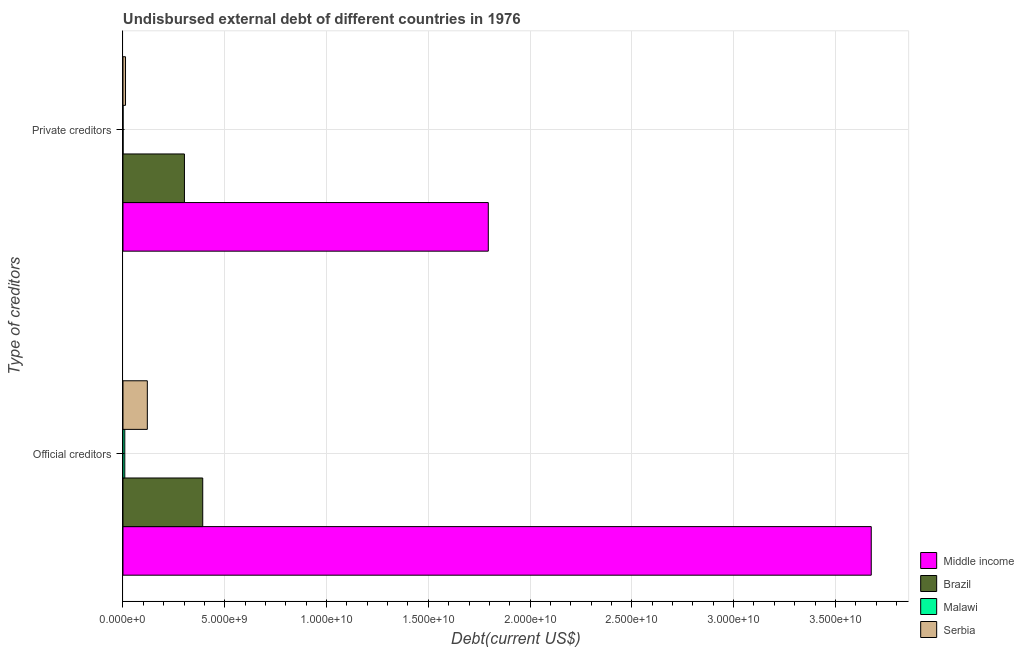How many different coloured bars are there?
Provide a short and direct response. 4. How many groups of bars are there?
Give a very brief answer. 2. Are the number of bars per tick equal to the number of legend labels?
Offer a very short reply. Yes. Are the number of bars on each tick of the Y-axis equal?
Your answer should be very brief. Yes. How many bars are there on the 2nd tick from the top?
Give a very brief answer. 4. What is the label of the 1st group of bars from the top?
Your answer should be very brief. Private creditors. What is the undisbursed external debt of private creditors in Malawi?
Your answer should be compact. 3.15e+06. Across all countries, what is the maximum undisbursed external debt of private creditors?
Offer a very short reply. 1.79e+1. Across all countries, what is the minimum undisbursed external debt of official creditors?
Make the answer very short. 8.95e+07. In which country was the undisbursed external debt of official creditors maximum?
Your answer should be very brief. Middle income. In which country was the undisbursed external debt of official creditors minimum?
Offer a terse response. Malawi. What is the total undisbursed external debt of private creditors in the graph?
Give a very brief answer. 2.11e+1. What is the difference between the undisbursed external debt of private creditors in Serbia and that in Brazil?
Offer a terse response. -2.89e+09. What is the difference between the undisbursed external debt of official creditors in Serbia and the undisbursed external debt of private creditors in Malawi?
Your answer should be very brief. 1.19e+09. What is the average undisbursed external debt of private creditors per country?
Provide a short and direct response. 5.27e+09. What is the difference between the undisbursed external debt of private creditors and undisbursed external debt of official creditors in Malawi?
Provide a succinct answer. -8.64e+07. In how many countries, is the undisbursed external debt of private creditors greater than 8000000000 US$?
Offer a very short reply. 1. What is the ratio of the undisbursed external debt of private creditors in Brazil to that in Malawi?
Provide a succinct answer. 958.53. In how many countries, is the undisbursed external debt of official creditors greater than the average undisbursed external debt of official creditors taken over all countries?
Offer a terse response. 1. What does the 3rd bar from the top in Private creditors represents?
Your answer should be compact. Brazil. How many countries are there in the graph?
Your answer should be very brief. 4. Are the values on the major ticks of X-axis written in scientific E-notation?
Provide a succinct answer. Yes. Does the graph contain any zero values?
Your answer should be very brief. No. Does the graph contain grids?
Give a very brief answer. Yes. How many legend labels are there?
Your answer should be very brief. 4. How are the legend labels stacked?
Keep it short and to the point. Vertical. What is the title of the graph?
Keep it short and to the point. Undisbursed external debt of different countries in 1976. What is the label or title of the X-axis?
Provide a succinct answer. Debt(current US$). What is the label or title of the Y-axis?
Your response must be concise. Type of creditors. What is the Debt(current US$) in Middle income in Official creditors?
Offer a very short reply. 3.68e+1. What is the Debt(current US$) of Brazil in Official creditors?
Keep it short and to the point. 3.92e+09. What is the Debt(current US$) of Malawi in Official creditors?
Offer a terse response. 8.95e+07. What is the Debt(current US$) in Serbia in Official creditors?
Your answer should be compact. 1.20e+09. What is the Debt(current US$) in Middle income in Private creditors?
Offer a very short reply. 1.79e+1. What is the Debt(current US$) of Brazil in Private creditors?
Offer a terse response. 3.02e+09. What is the Debt(current US$) in Malawi in Private creditors?
Your answer should be compact. 3.15e+06. What is the Debt(current US$) in Serbia in Private creditors?
Offer a very short reply. 1.24e+08. Across all Type of creditors, what is the maximum Debt(current US$) in Middle income?
Offer a very short reply. 3.68e+1. Across all Type of creditors, what is the maximum Debt(current US$) in Brazil?
Your answer should be compact. 3.92e+09. Across all Type of creditors, what is the maximum Debt(current US$) of Malawi?
Give a very brief answer. 8.95e+07. Across all Type of creditors, what is the maximum Debt(current US$) in Serbia?
Provide a short and direct response. 1.20e+09. Across all Type of creditors, what is the minimum Debt(current US$) of Middle income?
Your answer should be very brief. 1.79e+1. Across all Type of creditors, what is the minimum Debt(current US$) in Brazil?
Your response must be concise. 3.02e+09. Across all Type of creditors, what is the minimum Debt(current US$) of Malawi?
Provide a short and direct response. 3.15e+06. Across all Type of creditors, what is the minimum Debt(current US$) in Serbia?
Provide a succinct answer. 1.24e+08. What is the total Debt(current US$) of Middle income in the graph?
Ensure brevity in your answer.  5.47e+1. What is the total Debt(current US$) of Brazil in the graph?
Your answer should be compact. 6.94e+09. What is the total Debt(current US$) in Malawi in the graph?
Provide a short and direct response. 9.27e+07. What is the total Debt(current US$) of Serbia in the graph?
Your answer should be very brief. 1.32e+09. What is the difference between the Debt(current US$) in Middle income in Official creditors and that in Private creditors?
Your answer should be compact. 1.88e+1. What is the difference between the Debt(current US$) in Brazil in Official creditors and that in Private creditors?
Give a very brief answer. 8.99e+08. What is the difference between the Debt(current US$) of Malawi in Official creditors and that in Private creditors?
Your answer should be very brief. 8.64e+07. What is the difference between the Debt(current US$) of Serbia in Official creditors and that in Private creditors?
Keep it short and to the point. 1.07e+09. What is the difference between the Debt(current US$) of Middle income in Official creditors and the Debt(current US$) of Brazil in Private creditors?
Ensure brevity in your answer.  3.37e+1. What is the difference between the Debt(current US$) in Middle income in Official creditors and the Debt(current US$) in Malawi in Private creditors?
Your response must be concise. 3.68e+1. What is the difference between the Debt(current US$) of Middle income in Official creditors and the Debt(current US$) of Serbia in Private creditors?
Provide a short and direct response. 3.66e+1. What is the difference between the Debt(current US$) in Brazil in Official creditors and the Debt(current US$) in Malawi in Private creditors?
Provide a short and direct response. 3.91e+09. What is the difference between the Debt(current US$) of Brazil in Official creditors and the Debt(current US$) of Serbia in Private creditors?
Provide a short and direct response. 3.79e+09. What is the difference between the Debt(current US$) in Malawi in Official creditors and the Debt(current US$) in Serbia in Private creditors?
Your response must be concise. -3.49e+07. What is the average Debt(current US$) in Middle income per Type of creditors?
Offer a terse response. 2.74e+1. What is the average Debt(current US$) of Brazil per Type of creditors?
Make the answer very short. 3.47e+09. What is the average Debt(current US$) of Malawi per Type of creditors?
Keep it short and to the point. 4.63e+07. What is the average Debt(current US$) in Serbia per Type of creditors?
Your answer should be compact. 6.60e+08. What is the difference between the Debt(current US$) in Middle income and Debt(current US$) in Brazil in Official creditors?
Provide a short and direct response. 3.28e+1. What is the difference between the Debt(current US$) in Middle income and Debt(current US$) in Malawi in Official creditors?
Your answer should be very brief. 3.67e+1. What is the difference between the Debt(current US$) in Middle income and Debt(current US$) in Serbia in Official creditors?
Provide a succinct answer. 3.56e+1. What is the difference between the Debt(current US$) in Brazil and Debt(current US$) in Malawi in Official creditors?
Your answer should be very brief. 3.83e+09. What is the difference between the Debt(current US$) in Brazil and Debt(current US$) in Serbia in Official creditors?
Your answer should be very brief. 2.72e+09. What is the difference between the Debt(current US$) of Malawi and Debt(current US$) of Serbia in Official creditors?
Your answer should be very brief. -1.11e+09. What is the difference between the Debt(current US$) of Middle income and Debt(current US$) of Brazil in Private creditors?
Provide a succinct answer. 1.49e+1. What is the difference between the Debt(current US$) in Middle income and Debt(current US$) in Malawi in Private creditors?
Keep it short and to the point. 1.79e+1. What is the difference between the Debt(current US$) in Middle income and Debt(current US$) in Serbia in Private creditors?
Make the answer very short. 1.78e+1. What is the difference between the Debt(current US$) in Brazil and Debt(current US$) in Malawi in Private creditors?
Your answer should be compact. 3.02e+09. What is the difference between the Debt(current US$) of Brazil and Debt(current US$) of Serbia in Private creditors?
Keep it short and to the point. 2.89e+09. What is the difference between the Debt(current US$) of Malawi and Debt(current US$) of Serbia in Private creditors?
Provide a short and direct response. -1.21e+08. What is the ratio of the Debt(current US$) of Middle income in Official creditors to that in Private creditors?
Make the answer very short. 2.05. What is the ratio of the Debt(current US$) of Brazil in Official creditors to that in Private creditors?
Offer a very short reply. 1.3. What is the ratio of the Debt(current US$) of Malawi in Official creditors to that in Private creditors?
Give a very brief answer. 28.42. What is the ratio of the Debt(current US$) in Serbia in Official creditors to that in Private creditors?
Your response must be concise. 9.62. What is the difference between the highest and the second highest Debt(current US$) of Middle income?
Ensure brevity in your answer.  1.88e+1. What is the difference between the highest and the second highest Debt(current US$) of Brazil?
Offer a terse response. 8.99e+08. What is the difference between the highest and the second highest Debt(current US$) in Malawi?
Your response must be concise. 8.64e+07. What is the difference between the highest and the second highest Debt(current US$) in Serbia?
Keep it short and to the point. 1.07e+09. What is the difference between the highest and the lowest Debt(current US$) in Middle income?
Your answer should be very brief. 1.88e+1. What is the difference between the highest and the lowest Debt(current US$) of Brazil?
Offer a very short reply. 8.99e+08. What is the difference between the highest and the lowest Debt(current US$) in Malawi?
Ensure brevity in your answer.  8.64e+07. What is the difference between the highest and the lowest Debt(current US$) of Serbia?
Provide a short and direct response. 1.07e+09. 